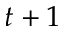<formula> <loc_0><loc_0><loc_500><loc_500>t + 1</formula> 